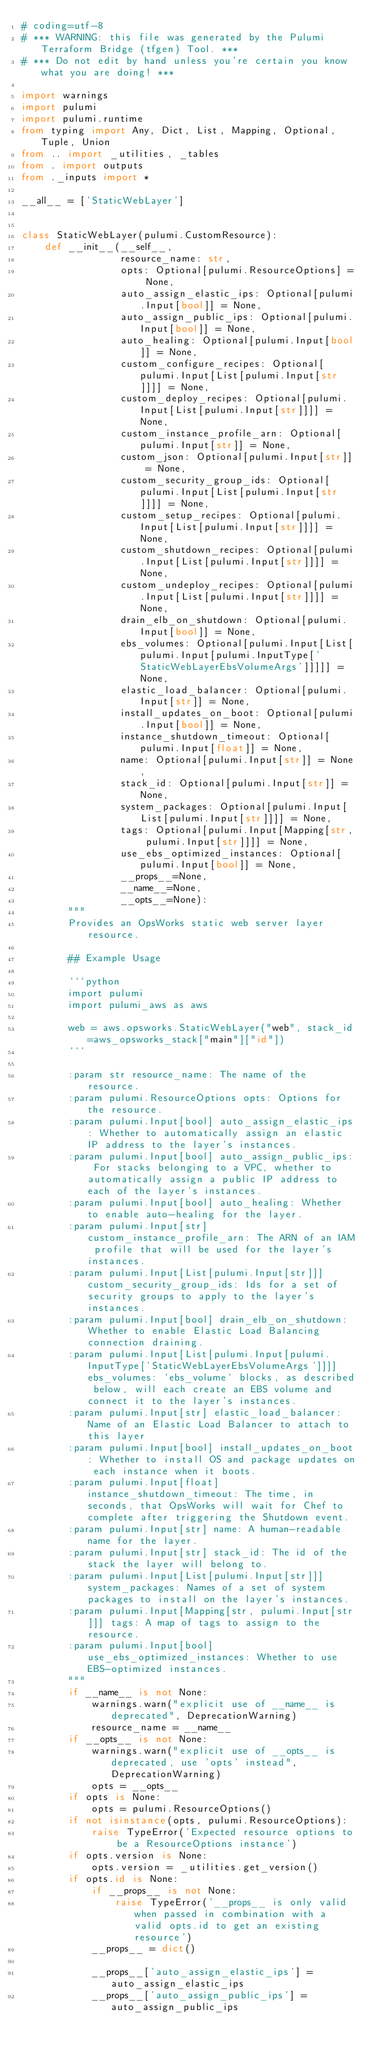<code> <loc_0><loc_0><loc_500><loc_500><_Python_># coding=utf-8
# *** WARNING: this file was generated by the Pulumi Terraform Bridge (tfgen) Tool. ***
# *** Do not edit by hand unless you're certain you know what you are doing! ***

import warnings
import pulumi
import pulumi.runtime
from typing import Any, Dict, List, Mapping, Optional, Tuple, Union
from .. import _utilities, _tables
from . import outputs
from ._inputs import *

__all__ = ['StaticWebLayer']


class StaticWebLayer(pulumi.CustomResource):
    def __init__(__self__,
                 resource_name: str,
                 opts: Optional[pulumi.ResourceOptions] = None,
                 auto_assign_elastic_ips: Optional[pulumi.Input[bool]] = None,
                 auto_assign_public_ips: Optional[pulumi.Input[bool]] = None,
                 auto_healing: Optional[pulumi.Input[bool]] = None,
                 custom_configure_recipes: Optional[pulumi.Input[List[pulumi.Input[str]]]] = None,
                 custom_deploy_recipes: Optional[pulumi.Input[List[pulumi.Input[str]]]] = None,
                 custom_instance_profile_arn: Optional[pulumi.Input[str]] = None,
                 custom_json: Optional[pulumi.Input[str]] = None,
                 custom_security_group_ids: Optional[pulumi.Input[List[pulumi.Input[str]]]] = None,
                 custom_setup_recipes: Optional[pulumi.Input[List[pulumi.Input[str]]]] = None,
                 custom_shutdown_recipes: Optional[pulumi.Input[List[pulumi.Input[str]]]] = None,
                 custom_undeploy_recipes: Optional[pulumi.Input[List[pulumi.Input[str]]]] = None,
                 drain_elb_on_shutdown: Optional[pulumi.Input[bool]] = None,
                 ebs_volumes: Optional[pulumi.Input[List[pulumi.Input[pulumi.InputType['StaticWebLayerEbsVolumeArgs']]]]] = None,
                 elastic_load_balancer: Optional[pulumi.Input[str]] = None,
                 install_updates_on_boot: Optional[pulumi.Input[bool]] = None,
                 instance_shutdown_timeout: Optional[pulumi.Input[float]] = None,
                 name: Optional[pulumi.Input[str]] = None,
                 stack_id: Optional[pulumi.Input[str]] = None,
                 system_packages: Optional[pulumi.Input[List[pulumi.Input[str]]]] = None,
                 tags: Optional[pulumi.Input[Mapping[str, pulumi.Input[str]]]] = None,
                 use_ebs_optimized_instances: Optional[pulumi.Input[bool]] = None,
                 __props__=None,
                 __name__=None,
                 __opts__=None):
        """
        Provides an OpsWorks static web server layer resource.

        ## Example Usage

        ```python
        import pulumi
        import pulumi_aws as aws

        web = aws.opsworks.StaticWebLayer("web", stack_id=aws_opsworks_stack["main"]["id"])
        ```

        :param str resource_name: The name of the resource.
        :param pulumi.ResourceOptions opts: Options for the resource.
        :param pulumi.Input[bool] auto_assign_elastic_ips: Whether to automatically assign an elastic IP address to the layer's instances.
        :param pulumi.Input[bool] auto_assign_public_ips: For stacks belonging to a VPC, whether to automatically assign a public IP address to each of the layer's instances.
        :param pulumi.Input[bool] auto_healing: Whether to enable auto-healing for the layer.
        :param pulumi.Input[str] custom_instance_profile_arn: The ARN of an IAM profile that will be used for the layer's instances.
        :param pulumi.Input[List[pulumi.Input[str]]] custom_security_group_ids: Ids for a set of security groups to apply to the layer's instances.
        :param pulumi.Input[bool] drain_elb_on_shutdown: Whether to enable Elastic Load Balancing connection draining.
        :param pulumi.Input[List[pulumi.Input[pulumi.InputType['StaticWebLayerEbsVolumeArgs']]]] ebs_volumes: `ebs_volume` blocks, as described below, will each create an EBS volume and connect it to the layer's instances.
        :param pulumi.Input[str] elastic_load_balancer: Name of an Elastic Load Balancer to attach to this layer
        :param pulumi.Input[bool] install_updates_on_boot: Whether to install OS and package updates on each instance when it boots.
        :param pulumi.Input[float] instance_shutdown_timeout: The time, in seconds, that OpsWorks will wait for Chef to complete after triggering the Shutdown event.
        :param pulumi.Input[str] name: A human-readable name for the layer.
        :param pulumi.Input[str] stack_id: The id of the stack the layer will belong to.
        :param pulumi.Input[List[pulumi.Input[str]]] system_packages: Names of a set of system packages to install on the layer's instances.
        :param pulumi.Input[Mapping[str, pulumi.Input[str]]] tags: A map of tags to assign to the resource.
        :param pulumi.Input[bool] use_ebs_optimized_instances: Whether to use EBS-optimized instances.
        """
        if __name__ is not None:
            warnings.warn("explicit use of __name__ is deprecated", DeprecationWarning)
            resource_name = __name__
        if __opts__ is not None:
            warnings.warn("explicit use of __opts__ is deprecated, use 'opts' instead", DeprecationWarning)
            opts = __opts__
        if opts is None:
            opts = pulumi.ResourceOptions()
        if not isinstance(opts, pulumi.ResourceOptions):
            raise TypeError('Expected resource options to be a ResourceOptions instance')
        if opts.version is None:
            opts.version = _utilities.get_version()
        if opts.id is None:
            if __props__ is not None:
                raise TypeError('__props__ is only valid when passed in combination with a valid opts.id to get an existing resource')
            __props__ = dict()

            __props__['auto_assign_elastic_ips'] = auto_assign_elastic_ips
            __props__['auto_assign_public_ips'] = auto_assign_public_ips</code> 